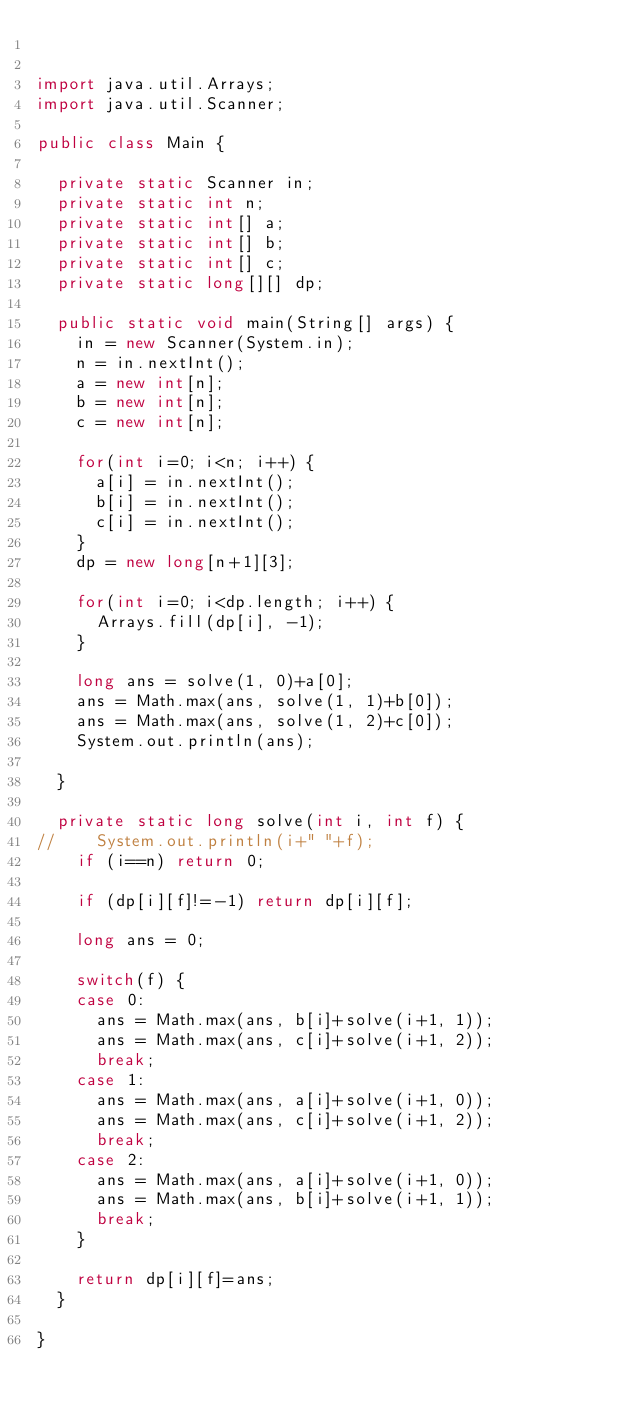<code> <loc_0><loc_0><loc_500><loc_500><_Java_>

import java.util.Arrays;
import java.util.Scanner;

public class Main {

	private static Scanner in;
	private static int n;
	private static int[] a;
	private static int[] b;
	private static int[] c;
	private static long[][] dp;
	
	public static void main(String[] args) {
		in = new Scanner(System.in);
		n = in.nextInt();
		a = new int[n];
		b = new int[n];
		c = new int[n];
		
		for(int i=0; i<n; i++) {
			a[i] = in.nextInt();
			b[i] = in.nextInt();
			c[i] = in.nextInt();
		}
		dp = new long[n+1][3];
		
		for(int i=0; i<dp.length; i++) {
			Arrays.fill(dp[i], -1);
		}
		
		long ans = solve(1, 0)+a[0];
		ans = Math.max(ans, solve(1, 1)+b[0]);
		ans = Math.max(ans, solve(1, 2)+c[0]);
		System.out.println(ans);

	}
	
	private static long solve(int i, int f) {
//		System.out.println(i+" "+f);
		if (i==n) return 0;
		
		if (dp[i][f]!=-1) return dp[i][f];
		
		long ans = 0;
		
		switch(f) {
		case 0:
			ans = Math.max(ans, b[i]+solve(i+1, 1));
			ans = Math.max(ans, c[i]+solve(i+1, 2));
			break;
		case 1:
			ans = Math.max(ans, a[i]+solve(i+1, 0));
			ans = Math.max(ans, c[i]+solve(i+1, 2));
			break;
		case 2:
			ans = Math.max(ans, a[i]+solve(i+1, 0));
			ans = Math.max(ans, b[i]+solve(i+1, 1));
			break;
		}
		
		return dp[i][f]=ans;
	}

}
</code> 